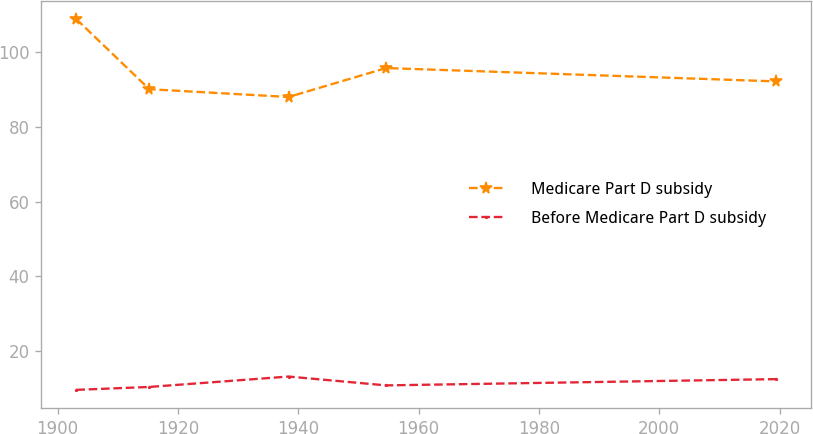Convert chart to OTSL. <chart><loc_0><loc_0><loc_500><loc_500><line_chart><ecel><fcel>Medicare Part D subsidy<fcel>Before Medicare Part D subsidy<nl><fcel>1903.12<fcel>108.92<fcel>9.52<nl><fcel>1915.25<fcel>90.13<fcel>10.3<nl><fcel>1938.4<fcel>88.04<fcel>13.09<nl><fcel>1954.61<fcel>95.8<fcel>10.72<nl><fcel>2019.43<fcel>92.22<fcel>12.4<nl></chart> 